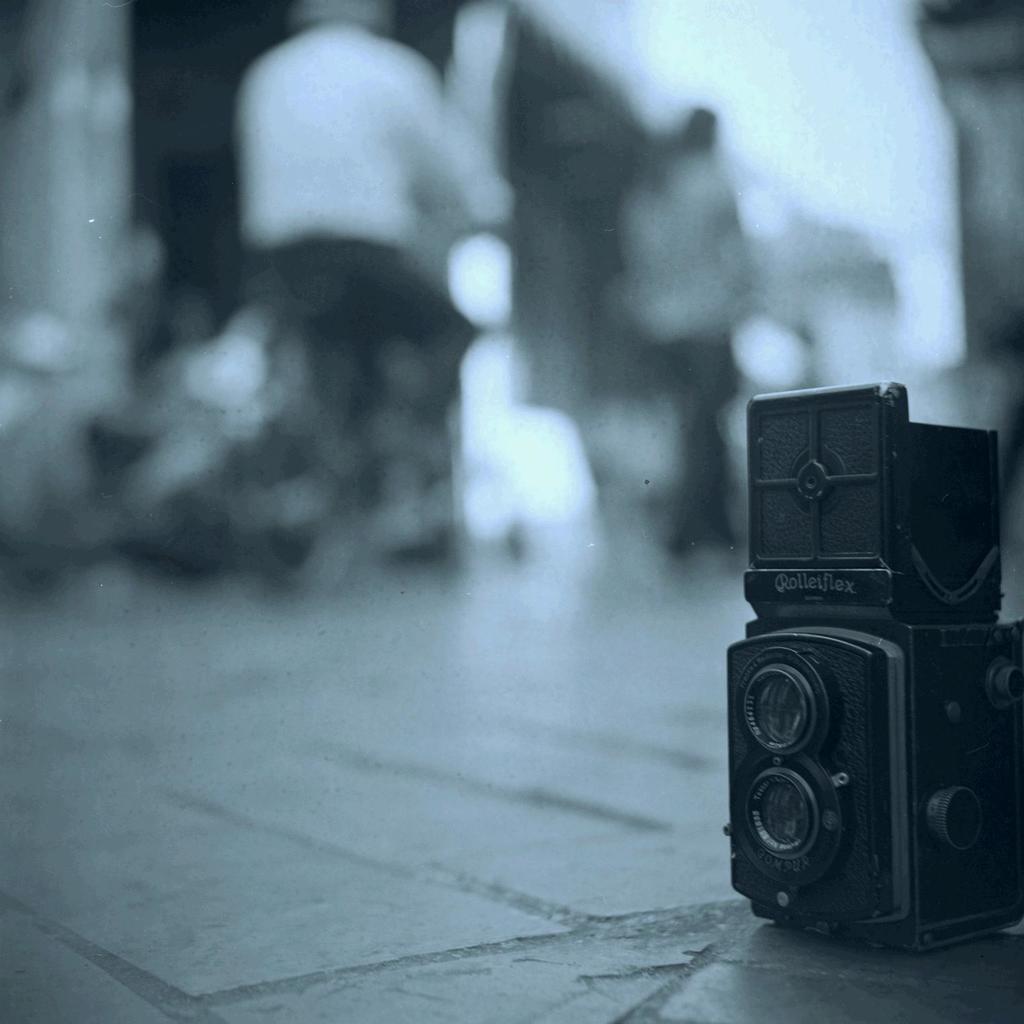Could you give a brief overview of what you see in this image? In this image we can a camera on the ground, there are two persons, and the background is blurred, also the picture is taken in black and white mode. 